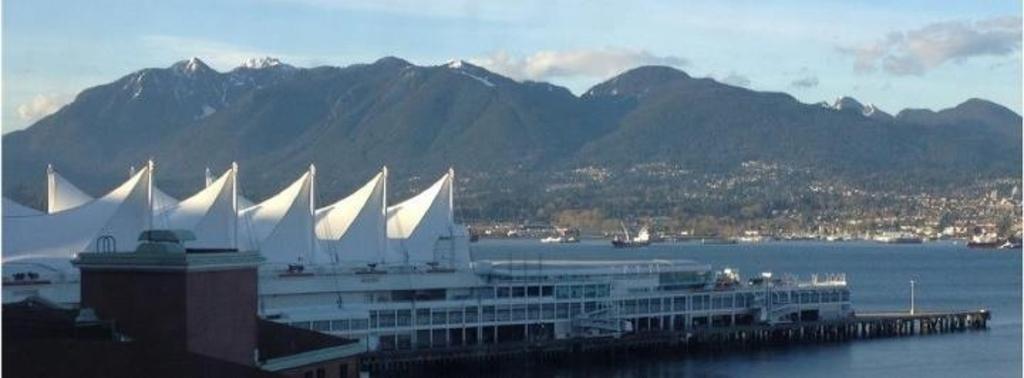Describe this image in one or two sentences. In this image we can see buildings, harbor, sea, ships, hills, sky and clouds. 